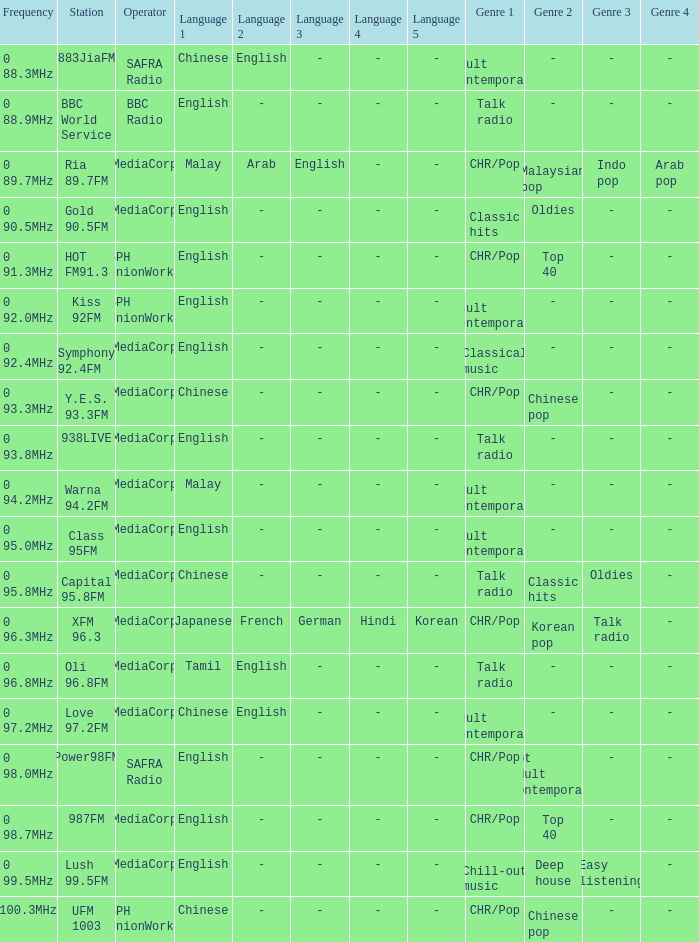Which station is operated by BBC Radio under the talk radio genre? BBC World Service. 